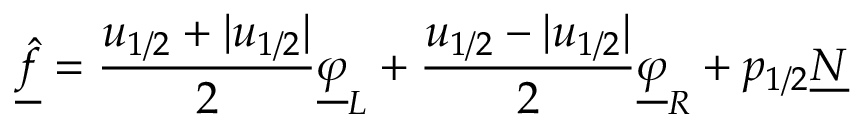Convert formula to latex. <formula><loc_0><loc_0><loc_500><loc_500>\underline { { \hat { f } } } = \frac { u _ { 1 / 2 } + | u _ { 1 / 2 } | } { 2 } \underline { \varphi } _ { L } + \frac { u _ { 1 / 2 } - | u _ { 1 / 2 } | } { 2 } \underline { \varphi } _ { R } + p _ { 1 / 2 } \underline { N }</formula> 